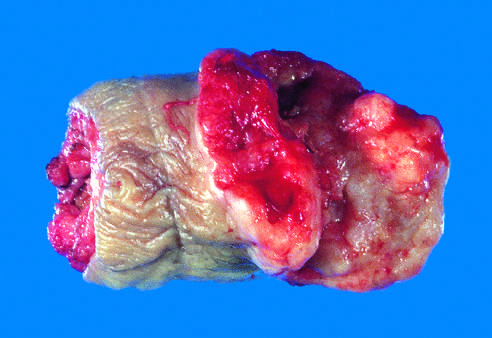what is the glans penis deformed by?
Answer the question using a single word or phrase. An ulcerated 